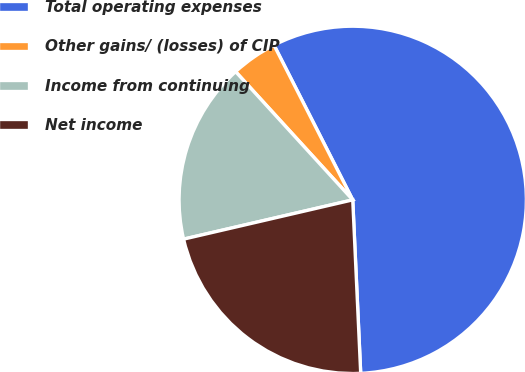<chart> <loc_0><loc_0><loc_500><loc_500><pie_chart><fcel>Total operating expenses<fcel>Other gains/ (losses) of CIP<fcel>Income from continuing<fcel>Net income<nl><fcel>56.76%<fcel>4.29%<fcel>16.85%<fcel>22.1%<nl></chart> 